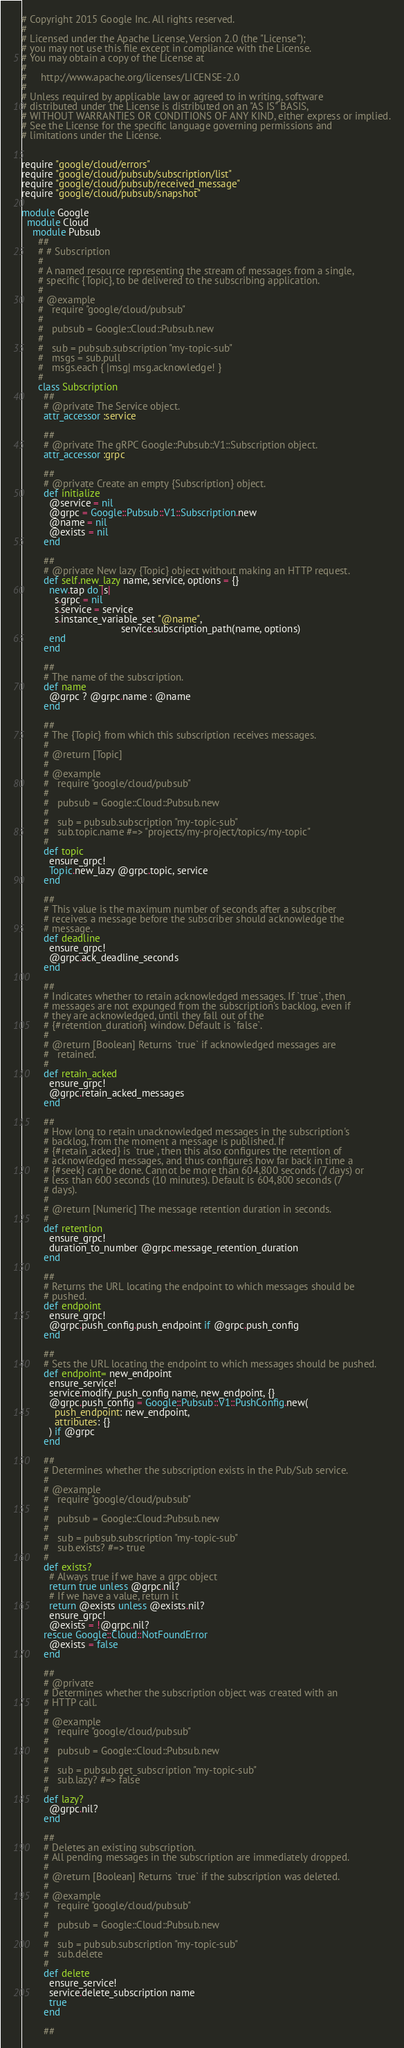<code> <loc_0><loc_0><loc_500><loc_500><_Ruby_># Copyright 2015 Google Inc. All rights reserved.
#
# Licensed under the Apache License, Version 2.0 (the "License");
# you may not use this file except in compliance with the License.
# You may obtain a copy of the License at
#
#     http://www.apache.org/licenses/LICENSE-2.0
#
# Unless required by applicable law or agreed to in writing, software
# distributed under the License is distributed on an "AS IS" BASIS,
# WITHOUT WARRANTIES OR CONDITIONS OF ANY KIND, either express or implied.
# See the License for the specific language governing permissions and
# limitations under the License.


require "google/cloud/errors"
require "google/cloud/pubsub/subscription/list"
require "google/cloud/pubsub/received_message"
require "google/cloud/pubsub/snapshot"

module Google
  module Cloud
    module Pubsub
      ##
      # # Subscription
      #
      # A named resource representing the stream of messages from a single,
      # specific {Topic}, to be delivered to the subscribing application.
      #
      # @example
      #   require "google/cloud/pubsub"
      #
      #   pubsub = Google::Cloud::Pubsub.new
      #
      #   sub = pubsub.subscription "my-topic-sub"
      #   msgs = sub.pull
      #   msgs.each { |msg| msg.acknowledge! }
      #
      class Subscription
        ##
        # @private The Service object.
        attr_accessor :service

        ##
        # @private The gRPC Google::Pubsub::V1::Subscription object.
        attr_accessor :grpc

        ##
        # @private Create an empty {Subscription} object.
        def initialize
          @service = nil
          @grpc = Google::Pubsub::V1::Subscription.new
          @name = nil
          @exists = nil
        end

        ##
        # @private New lazy {Topic} object without making an HTTP request.
        def self.new_lazy name, service, options = {}
          new.tap do |s|
            s.grpc = nil
            s.service = service
            s.instance_variable_set "@name",
                                    service.subscription_path(name, options)
          end
        end

        ##
        # The name of the subscription.
        def name
          @grpc ? @grpc.name : @name
        end

        ##
        # The {Topic} from which this subscription receives messages.
        #
        # @return [Topic]
        #
        # @example
        #   require "google/cloud/pubsub"
        #
        #   pubsub = Google::Cloud::Pubsub.new
        #
        #   sub = pubsub.subscription "my-topic-sub"
        #   sub.topic.name #=> "projects/my-project/topics/my-topic"
        #
        def topic
          ensure_grpc!
          Topic.new_lazy @grpc.topic, service
        end

        ##
        # This value is the maximum number of seconds after a subscriber
        # receives a message before the subscriber should acknowledge the
        # message.
        def deadline
          ensure_grpc!
          @grpc.ack_deadline_seconds
        end

        ##
        # Indicates whether to retain acknowledged messages. If `true`, then
        # messages are not expunged from the subscription's backlog, even if
        # they are acknowledged, until they fall out of the
        # {#retention_duration} window. Default is `false`.
        #
        # @return [Boolean] Returns `true` if acknowledged messages are
        #   retained.
        #
        def retain_acked
          ensure_grpc!
          @grpc.retain_acked_messages
        end

        ##
        # How long to retain unacknowledged messages in the subscription's
        # backlog, from the moment a message is published. If
        # {#retain_acked} is `true`, then this also configures the retention of
        # acknowledged messages, and thus configures how far back in time a
        # {#seek} can be done. Cannot be more than 604,800 seconds (7 days) or
        # less than 600 seconds (10 minutes). Default is 604,800 seconds (7
        # days).
        #
        # @return [Numeric] The message retention duration in seconds.
        #
        def retention
          ensure_grpc!
          duration_to_number @grpc.message_retention_duration
        end

        ##
        # Returns the URL locating the endpoint to which messages should be
        # pushed.
        def endpoint
          ensure_grpc!
          @grpc.push_config.push_endpoint if @grpc.push_config
        end

        ##
        # Sets the URL locating the endpoint to which messages should be pushed.
        def endpoint= new_endpoint
          ensure_service!
          service.modify_push_config name, new_endpoint, {}
          @grpc.push_config = Google::Pubsub::V1::PushConfig.new(
            push_endpoint: new_endpoint,
            attributes: {}
          ) if @grpc
        end

        ##
        # Determines whether the subscription exists in the Pub/Sub service.
        #
        # @example
        #   require "google/cloud/pubsub"
        #
        #   pubsub = Google::Cloud::Pubsub.new
        #
        #   sub = pubsub.subscription "my-topic-sub"
        #   sub.exists? #=> true
        #
        def exists?
          # Always true if we have a grpc object
          return true unless @grpc.nil?
          # If we have a value, return it
          return @exists unless @exists.nil?
          ensure_grpc!
          @exists = !@grpc.nil?
        rescue Google::Cloud::NotFoundError
          @exists = false
        end

        ##
        # @private
        # Determines whether the subscription object was created with an
        # HTTP call.
        #
        # @example
        #   require "google/cloud/pubsub"
        #
        #   pubsub = Google::Cloud::Pubsub.new
        #
        #   sub = pubsub.get_subscription "my-topic-sub"
        #   sub.lazy? #=> false
        #
        def lazy?
          @grpc.nil?
        end

        ##
        # Deletes an existing subscription.
        # All pending messages in the subscription are immediately dropped.
        #
        # @return [Boolean] Returns `true` if the subscription was deleted.
        #
        # @example
        #   require "google/cloud/pubsub"
        #
        #   pubsub = Google::Cloud::Pubsub.new
        #
        #   sub = pubsub.subscription "my-topic-sub"
        #   sub.delete
        #
        def delete
          ensure_service!
          service.delete_subscription name
          true
        end

        ##</code> 